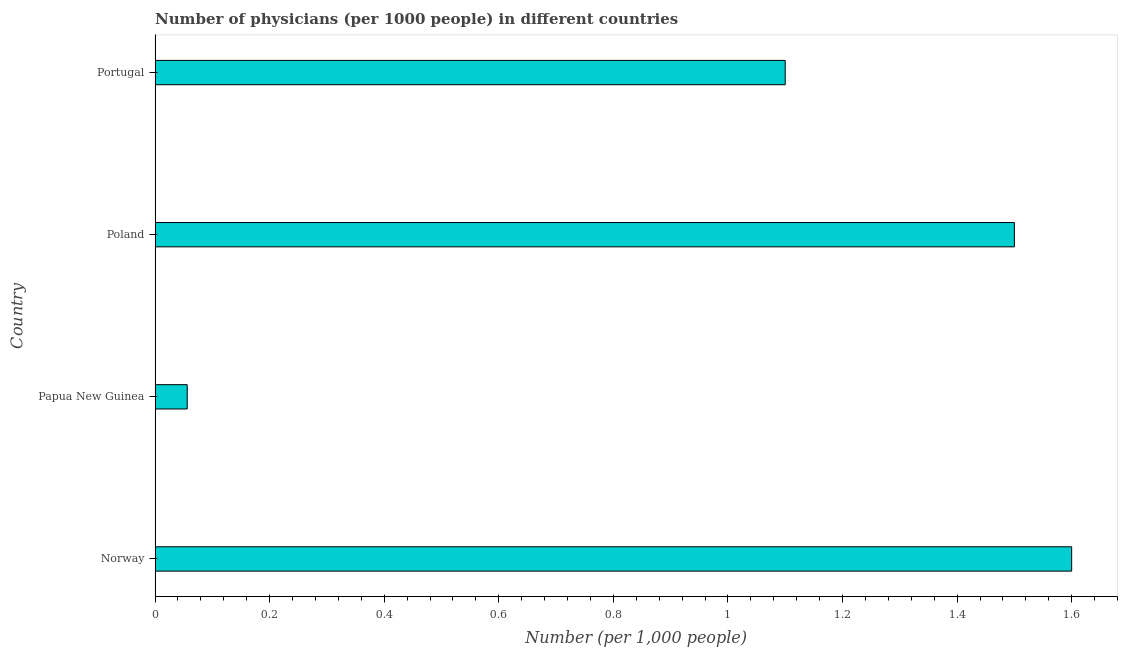Does the graph contain grids?
Give a very brief answer. No. What is the title of the graph?
Your response must be concise. Number of physicians (per 1000 people) in different countries. What is the label or title of the X-axis?
Keep it short and to the point. Number (per 1,0 people). What is the number of physicians in Portugal?
Your answer should be compact. 1.1. Across all countries, what is the maximum number of physicians?
Give a very brief answer. 1.6. Across all countries, what is the minimum number of physicians?
Offer a terse response. 0.06. In which country was the number of physicians maximum?
Provide a short and direct response. Norway. In which country was the number of physicians minimum?
Make the answer very short. Papua New Guinea. What is the sum of the number of physicians?
Provide a short and direct response. 4.26. What is the difference between the number of physicians in Norway and Papua New Guinea?
Ensure brevity in your answer.  1.54. What is the average number of physicians per country?
Your answer should be very brief. 1.06. What is the median number of physicians?
Your answer should be very brief. 1.3. In how many countries, is the number of physicians greater than 0.24 ?
Your answer should be very brief. 3. What is the ratio of the number of physicians in Poland to that in Portugal?
Ensure brevity in your answer.  1.36. Is the difference between the number of physicians in Papua New Guinea and Portugal greater than the difference between any two countries?
Keep it short and to the point. No. What is the difference between the highest and the second highest number of physicians?
Your answer should be compact. 0.1. Is the sum of the number of physicians in Norway and Papua New Guinea greater than the maximum number of physicians across all countries?
Give a very brief answer. Yes. What is the difference between the highest and the lowest number of physicians?
Your answer should be very brief. 1.54. In how many countries, is the number of physicians greater than the average number of physicians taken over all countries?
Provide a succinct answer. 3. How many bars are there?
Provide a succinct answer. 4. How many countries are there in the graph?
Give a very brief answer. 4. What is the difference between two consecutive major ticks on the X-axis?
Your response must be concise. 0.2. What is the Number (per 1,000 people) of Norway?
Offer a very short reply. 1.6. What is the Number (per 1,000 people) of Papua New Guinea?
Your answer should be compact. 0.06. What is the Number (per 1,000 people) in Poland?
Make the answer very short. 1.5. What is the difference between the Number (per 1,000 people) in Norway and Papua New Guinea?
Keep it short and to the point. 1.54. What is the difference between the Number (per 1,000 people) in Norway and Poland?
Ensure brevity in your answer.  0.1. What is the difference between the Number (per 1,000 people) in Norway and Portugal?
Give a very brief answer. 0.5. What is the difference between the Number (per 1,000 people) in Papua New Guinea and Poland?
Provide a succinct answer. -1.44. What is the difference between the Number (per 1,000 people) in Papua New Guinea and Portugal?
Provide a succinct answer. -1.04. What is the ratio of the Number (per 1,000 people) in Norway to that in Papua New Guinea?
Give a very brief answer. 28.52. What is the ratio of the Number (per 1,000 people) in Norway to that in Poland?
Ensure brevity in your answer.  1.07. What is the ratio of the Number (per 1,000 people) in Norway to that in Portugal?
Provide a succinct answer. 1.46. What is the ratio of the Number (per 1,000 people) in Papua New Guinea to that in Poland?
Make the answer very short. 0.04. What is the ratio of the Number (per 1,000 people) in Papua New Guinea to that in Portugal?
Provide a succinct answer. 0.05. What is the ratio of the Number (per 1,000 people) in Poland to that in Portugal?
Offer a very short reply. 1.36. 